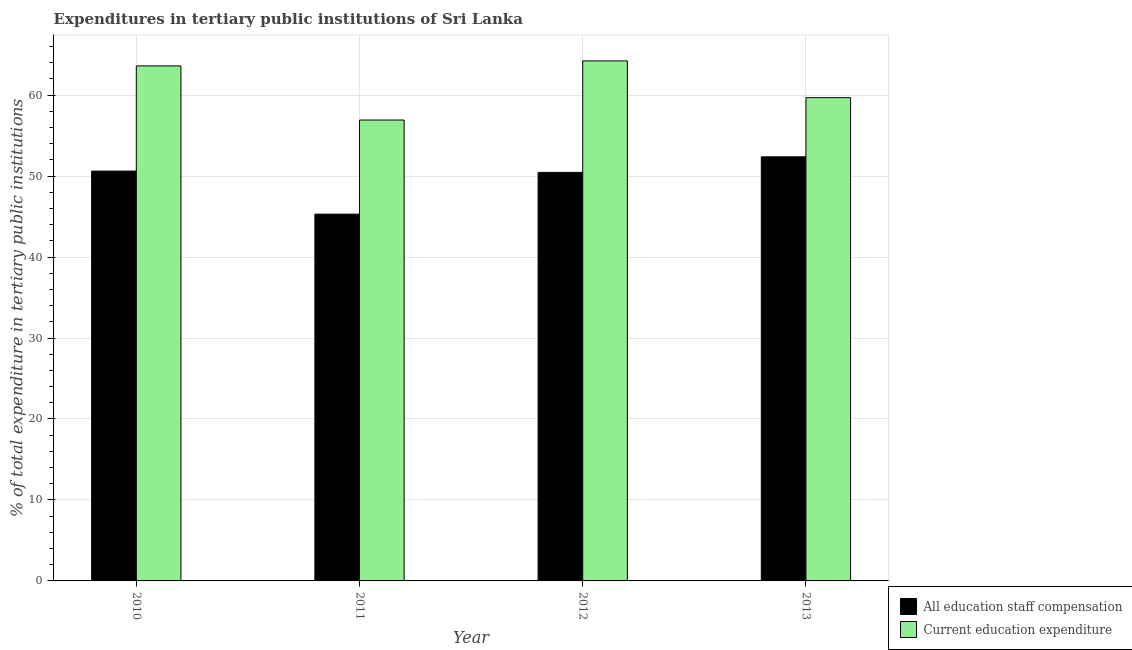How many different coloured bars are there?
Make the answer very short. 2. How many groups of bars are there?
Your answer should be very brief. 4. Are the number of bars per tick equal to the number of legend labels?
Provide a short and direct response. Yes. How many bars are there on the 4th tick from the right?
Offer a very short reply. 2. What is the label of the 3rd group of bars from the left?
Your response must be concise. 2012. In how many cases, is the number of bars for a given year not equal to the number of legend labels?
Provide a succinct answer. 0. What is the expenditure in staff compensation in 2010?
Offer a terse response. 50.61. Across all years, what is the maximum expenditure in education?
Your response must be concise. 64.23. Across all years, what is the minimum expenditure in staff compensation?
Your response must be concise. 45.3. In which year was the expenditure in education minimum?
Your answer should be compact. 2011. What is the total expenditure in staff compensation in the graph?
Ensure brevity in your answer.  198.74. What is the difference between the expenditure in staff compensation in 2011 and that in 2013?
Give a very brief answer. -7.08. What is the difference between the expenditure in education in 2013 and the expenditure in staff compensation in 2010?
Make the answer very short. -3.92. What is the average expenditure in education per year?
Offer a terse response. 61.11. In how many years, is the expenditure in staff compensation greater than 64 %?
Your answer should be compact. 0. What is the ratio of the expenditure in staff compensation in 2011 to that in 2013?
Provide a succinct answer. 0.86. Is the expenditure in staff compensation in 2010 less than that in 2012?
Offer a very short reply. No. What is the difference between the highest and the second highest expenditure in staff compensation?
Offer a very short reply. 1.76. What is the difference between the highest and the lowest expenditure in staff compensation?
Make the answer very short. 7.08. Is the sum of the expenditure in staff compensation in 2010 and 2011 greater than the maximum expenditure in education across all years?
Give a very brief answer. Yes. What does the 1st bar from the left in 2010 represents?
Keep it short and to the point. All education staff compensation. What does the 1st bar from the right in 2013 represents?
Ensure brevity in your answer.  Current education expenditure. How many bars are there?
Give a very brief answer. 8. Are all the bars in the graph horizontal?
Make the answer very short. No. What is the difference between two consecutive major ticks on the Y-axis?
Offer a terse response. 10. Does the graph contain grids?
Offer a terse response. Yes. What is the title of the graph?
Provide a succinct answer. Expenditures in tertiary public institutions of Sri Lanka. Does "Fixed telephone" appear as one of the legend labels in the graph?
Offer a terse response. No. What is the label or title of the X-axis?
Offer a very short reply. Year. What is the label or title of the Y-axis?
Your answer should be very brief. % of total expenditure in tertiary public institutions. What is the % of total expenditure in tertiary public institutions in All education staff compensation in 2010?
Make the answer very short. 50.61. What is the % of total expenditure in tertiary public institutions in Current education expenditure in 2010?
Offer a terse response. 63.61. What is the % of total expenditure in tertiary public institutions of All education staff compensation in 2011?
Offer a terse response. 45.3. What is the % of total expenditure in tertiary public institutions of Current education expenditure in 2011?
Keep it short and to the point. 56.92. What is the % of total expenditure in tertiary public institutions of All education staff compensation in 2012?
Offer a very short reply. 50.45. What is the % of total expenditure in tertiary public institutions of Current education expenditure in 2012?
Provide a short and direct response. 64.23. What is the % of total expenditure in tertiary public institutions in All education staff compensation in 2013?
Provide a short and direct response. 52.38. What is the % of total expenditure in tertiary public institutions of Current education expenditure in 2013?
Keep it short and to the point. 59.68. Across all years, what is the maximum % of total expenditure in tertiary public institutions in All education staff compensation?
Provide a succinct answer. 52.38. Across all years, what is the maximum % of total expenditure in tertiary public institutions of Current education expenditure?
Your response must be concise. 64.23. Across all years, what is the minimum % of total expenditure in tertiary public institutions of All education staff compensation?
Offer a terse response. 45.3. Across all years, what is the minimum % of total expenditure in tertiary public institutions in Current education expenditure?
Provide a short and direct response. 56.92. What is the total % of total expenditure in tertiary public institutions in All education staff compensation in the graph?
Offer a terse response. 198.74. What is the total % of total expenditure in tertiary public institutions of Current education expenditure in the graph?
Your answer should be very brief. 244.44. What is the difference between the % of total expenditure in tertiary public institutions in All education staff compensation in 2010 and that in 2011?
Provide a short and direct response. 5.32. What is the difference between the % of total expenditure in tertiary public institutions of Current education expenditure in 2010 and that in 2011?
Keep it short and to the point. 6.69. What is the difference between the % of total expenditure in tertiary public institutions of All education staff compensation in 2010 and that in 2012?
Offer a terse response. 0.16. What is the difference between the % of total expenditure in tertiary public institutions of Current education expenditure in 2010 and that in 2012?
Offer a terse response. -0.62. What is the difference between the % of total expenditure in tertiary public institutions in All education staff compensation in 2010 and that in 2013?
Provide a short and direct response. -1.76. What is the difference between the % of total expenditure in tertiary public institutions of Current education expenditure in 2010 and that in 2013?
Your answer should be compact. 3.92. What is the difference between the % of total expenditure in tertiary public institutions in All education staff compensation in 2011 and that in 2012?
Keep it short and to the point. -5.16. What is the difference between the % of total expenditure in tertiary public institutions of Current education expenditure in 2011 and that in 2012?
Keep it short and to the point. -7.31. What is the difference between the % of total expenditure in tertiary public institutions in All education staff compensation in 2011 and that in 2013?
Offer a terse response. -7.08. What is the difference between the % of total expenditure in tertiary public institutions in Current education expenditure in 2011 and that in 2013?
Your response must be concise. -2.76. What is the difference between the % of total expenditure in tertiary public institutions in All education staff compensation in 2012 and that in 2013?
Make the answer very short. -1.92. What is the difference between the % of total expenditure in tertiary public institutions in Current education expenditure in 2012 and that in 2013?
Provide a succinct answer. 4.54. What is the difference between the % of total expenditure in tertiary public institutions in All education staff compensation in 2010 and the % of total expenditure in tertiary public institutions in Current education expenditure in 2011?
Offer a terse response. -6.31. What is the difference between the % of total expenditure in tertiary public institutions of All education staff compensation in 2010 and the % of total expenditure in tertiary public institutions of Current education expenditure in 2012?
Your response must be concise. -13.61. What is the difference between the % of total expenditure in tertiary public institutions in All education staff compensation in 2010 and the % of total expenditure in tertiary public institutions in Current education expenditure in 2013?
Make the answer very short. -9.07. What is the difference between the % of total expenditure in tertiary public institutions of All education staff compensation in 2011 and the % of total expenditure in tertiary public institutions of Current education expenditure in 2012?
Your response must be concise. -18.93. What is the difference between the % of total expenditure in tertiary public institutions in All education staff compensation in 2011 and the % of total expenditure in tertiary public institutions in Current education expenditure in 2013?
Ensure brevity in your answer.  -14.39. What is the difference between the % of total expenditure in tertiary public institutions of All education staff compensation in 2012 and the % of total expenditure in tertiary public institutions of Current education expenditure in 2013?
Give a very brief answer. -9.23. What is the average % of total expenditure in tertiary public institutions of All education staff compensation per year?
Your response must be concise. 49.69. What is the average % of total expenditure in tertiary public institutions of Current education expenditure per year?
Your answer should be very brief. 61.11. In the year 2010, what is the difference between the % of total expenditure in tertiary public institutions in All education staff compensation and % of total expenditure in tertiary public institutions in Current education expenditure?
Make the answer very short. -12.99. In the year 2011, what is the difference between the % of total expenditure in tertiary public institutions of All education staff compensation and % of total expenditure in tertiary public institutions of Current education expenditure?
Give a very brief answer. -11.62. In the year 2012, what is the difference between the % of total expenditure in tertiary public institutions in All education staff compensation and % of total expenditure in tertiary public institutions in Current education expenditure?
Provide a succinct answer. -13.77. In the year 2013, what is the difference between the % of total expenditure in tertiary public institutions of All education staff compensation and % of total expenditure in tertiary public institutions of Current education expenditure?
Make the answer very short. -7.31. What is the ratio of the % of total expenditure in tertiary public institutions in All education staff compensation in 2010 to that in 2011?
Offer a very short reply. 1.12. What is the ratio of the % of total expenditure in tertiary public institutions in Current education expenditure in 2010 to that in 2011?
Keep it short and to the point. 1.12. What is the ratio of the % of total expenditure in tertiary public institutions of All education staff compensation in 2010 to that in 2012?
Your answer should be very brief. 1. What is the ratio of the % of total expenditure in tertiary public institutions in All education staff compensation in 2010 to that in 2013?
Offer a very short reply. 0.97. What is the ratio of the % of total expenditure in tertiary public institutions of Current education expenditure in 2010 to that in 2013?
Offer a terse response. 1.07. What is the ratio of the % of total expenditure in tertiary public institutions in All education staff compensation in 2011 to that in 2012?
Offer a terse response. 0.9. What is the ratio of the % of total expenditure in tertiary public institutions in Current education expenditure in 2011 to that in 2012?
Provide a short and direct response. 0.89. What is the ratio of the % of total expenditure in tertiary public institutions in All education staff compensation in 2011 to that in 2013?
Your answer should be very brief. 0.86. What is the ratio of the % of total expenditure in tertiary public institutions in Current education expenditure in 2011 to that in 2013?
Your answer should be very brief. 0.95. What is the ratio of the % of total expenditure in tertiary public institutions of All education staff compensation in 2012 to that in 2013?
Give a very brief answer. 0.96. What is the ratio of the % of total expenditure in tertiary public institutions in Current education expenditure in 2012 to that in 2013?
Offer a very short reply. 1.08. What is the difference between the highest and the second highest % of total expenditure in tertiary public institutions in All education staff compensation?
Ensure brevity in your answer.  1.76. What is the difference between the highest and the second highest % of total expenditure in tertiary public institutions of Current education expenditure?
Give a very brief answer. 0.62. What is the difference between the highest and the lowest % of total expenditure in tertiary public institutions of All education staff compensation?
Your answer should be very brief. 7.08. What is the difference between the highest and the lowest % of total expenditure in tertiary public institutions of Current education expenditure?
Offer a terse response. 7.31. 